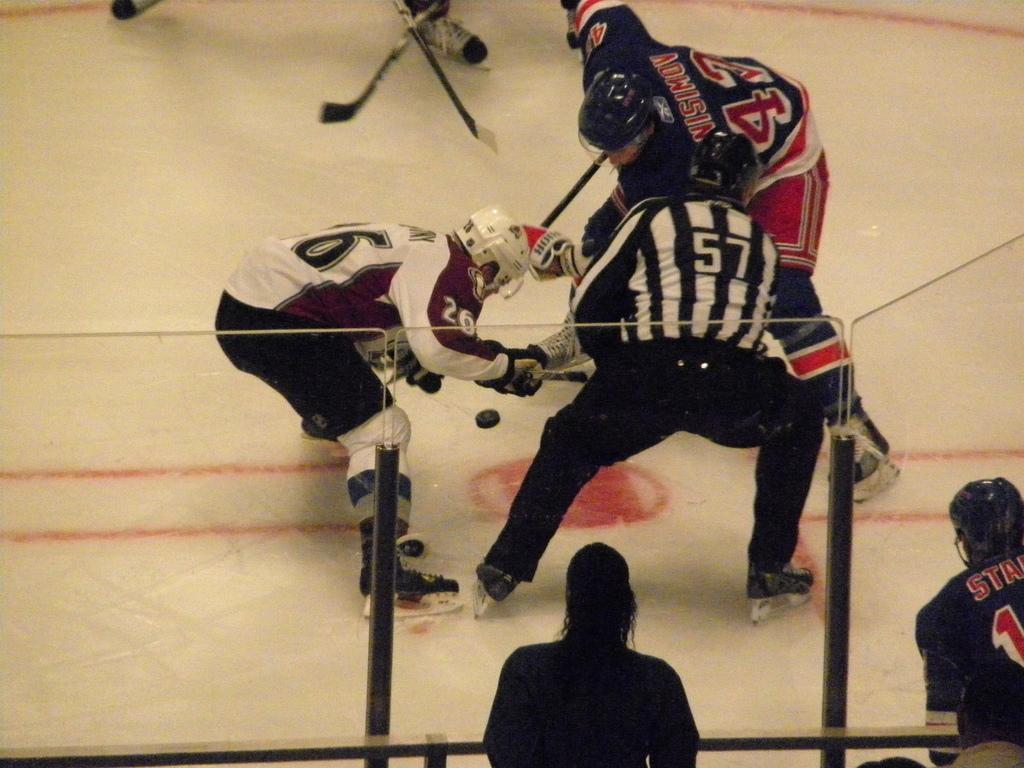In one or two sentences, can you explain what this image depicts? In the center of the image we can see some persons are playing and wearing skating shoes, helmet, gloves and holding hockey sticks. At the bottom of the image we can see glass wall and some persons. In the background of the image we can see the floor. 